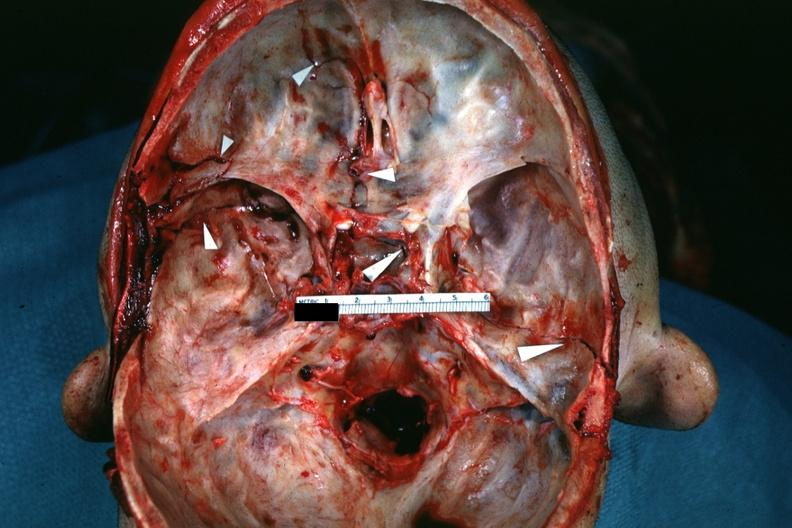what does this image show?
Answer the question using a single word or phrase. Fractures brain which is slide and close-up view of these fractures is slide 